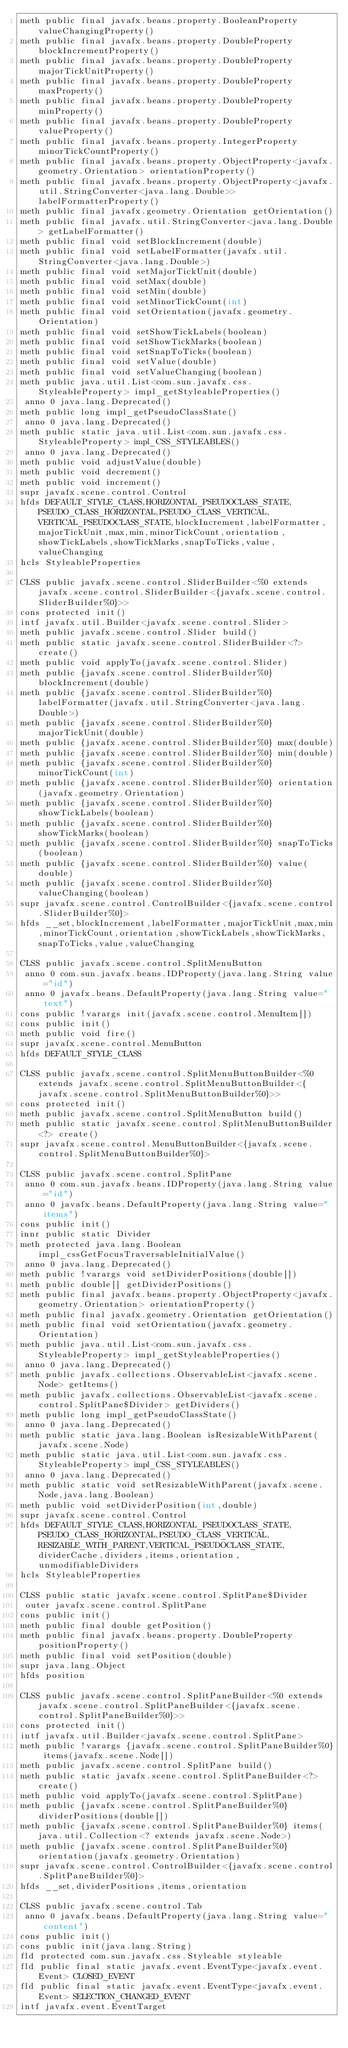<code> <loc_0><loc_0><loc_500><loc_500><_SML_>meth public final javafx.beans.property.BooleanProperty valueChangingProperty()
meth public final javafx.beans.property.DoubleProperty blockIncrementProperty()
meth public final javafx.beans.property.DoubleProperty majorTickUnitProperty()
meth public final javafx.beans.property.DoubleProperty maxProperty()
meth public final javafx.beans.property.DoubleProperty minProperty()
meth public final javafx.beans.property.DoubleProperty valueProperty()
meth public final javafx.beans.property.IntegerProperty minorTickCountProperty()
meth public final javafx.beans.property.ObjectProperty<javafx.geometry.Orientation> orientationProperty()
meth public final javafx.beans.property.ObjectProperty<javafx.util.StringConverter<java.lang.Double>> labelFormatterProperty()
meth public final javafx.geometry.Orientation getOrientation()
meth public final javafx.util.StringConverter<java.lang.Double> getLabelFormatter()
meth public final void setBlockIncrement(double)
meth public final void setLabelFormatter(javafx.util.StringConverter<java.lang.Double>)
meth public final void setMajorTickUnit(double)
meth public final void setMax(double)
meth public final void setMin(double)
meth public final void setMinorTickCount(int)
meth public final void setOrientation(javafx.geometry.Orientation)
meth public final void setShowTickLabels(boolean)
meth public final void setShowTickMarks(boolean)
meth public final void setSnapToTicks(boolean)
meth public final void setValue(double)
meth public final void setValueChanging(boolean)
meth public java.util.List<com.sun.javafx.css.StyleableProperty> impl_getStyleableProperties()
 anno 0 java.lang.Deprecated()
meth public long impl_getPseudoClassState()
 anno 0 java.lang.Deprecated()
meth public static java.util.List<com.sun.javafx.css.StyleableProperty> impl_CSS_STYLEABLES()
 anno 0 java.lang.Deprecated()
meth public void adjustValue(double)
meth public void decrement()
meth public void increment()
supr javafx.scene.control.Control
hfds DEFAULT_STYLE_CLASS,HORIZONTAL_PSEUDOCLASS_STATE,PSEUDO_CLASS_HORIZONTAL,PSEUDO_CLASS_VERTICAL,VERTICAL_PSEUDOCLASS_STATE,blockIncrement,labelFormatter,majorTickUnit,max,min,minorTickCount,orientation,showTickLabels,showTickMarks,snapToTicks,value,valueChanging
hcls StyleableProperties

CLSS public javafx.scene.control.SliderBuilder<%0 extends javafx.scene.control.SliderBuilder<{javafx.scene.control.SliderBuilder%0}>>
cons protected init()
intf javafx.util.Builder<javafx.scene.control.Slider>
meth public javafx.scene.control.Slider build()
meth public static javafx.scene.control.SliderBuilder<?> create()
meth public void applyTo(javafx.scene.control.Slider)
meth public {javafx.scene.control.SliderBuilder%0} blockIncrement(double)
meth public {javafx.scene.control.SliderBuilder%0} labelFormatter(javafx.util.StringConverter<java.lang.Double>)
meth public {javafx.scene.control.SliderBuilder%0} majorTickUnit(double)
meth public {javafx.scene.control.SliderBuilder%0} max(double)
meth public {javafx.scene.control.SliderBuilder%0} min(double)
meth public {javafx.scene.control.SliderBuilder%0} minorTickCount(int)
meth public {javafx.scene.control.SliderBuilder%0} orientation(javafx.geometry.Orientation)
meth public {javafx.scene.control.SliderBuilder%0} showTickLabels(boolean)
meth public {javafx.scene.control.SliderBuilder%0} showTickMarks(boolean)
meth public {javafx.scene.control.SliderBuilder%0} snapToTicks(boolean)
meth public {javafx.scene.control.SliderBuilder%0} value(double)
meth public {javafx.scene.control.SliderBuilder%0} valueChanging(boolean)
supr javafx.scene.control.ControlBuilder<{javafx.scene.control.SliderBuilder%0}>
hfds __set,blockIncrement,labelFormatter,majorTickUnit,max,min,minorTickCount,orientation,showTickLabels,showTickMarks,snapToTicks,value,valueChanging

CLSS public javafx.scene.control.SplitMenuButton
 anno 0 com.sun.javafx.beans.IDProperty(java.lang.String value="id")
 anno 0 javafx.beans.DefaultProperty(java.lang.String value="text")
cons public !varargs init(javafx.scene.control.MenuItem[])
cons public init()
meth public void fire()
supr javafx.scene.control.MenuButton
hfds DEFAULT_STYLE_CLASS

CLSS public javafx.scene.control.SplitMenuButtonBuilder<%0 extends javafx.scene.control.SplitMenuButtonBuilder<{javafx.scene.control.SplitMenuButtonBuilder%0}>>
cons protected init()
meth public javafx.scene.control.SplitMenuButton build()
meth public static javafx.scene.control.SplitMenuButtonBuilder<?> create()
supr javafx.scene.control.MenuButtonBuilder<{javafx.scene.control.SplitMenuButtonBuilder%0}>

CLSS public javafx.scene.control.SplitPane
 anno 0 com.sun.javafx.beans.IDProperty(java.lang.String value="id")
 anno 0 javafx.beans.DefaultProperty(java.lang.String value="items")
cons public init()
innr public static Divider
meth protected java.lang.Boolean impl_cssGetFocusTraversableInitialValue()
 anno 0 java.lang.Deprecated()
meth public !varargs void setDividerPositions(double[])
meth public double[] getDividerPositions()
meth public final javafx.beans.property.ObjectProperty<javafx.geometry.Orientation> orientationProperty()
meth public final javafx.geometry.Orientation getOrientation()
meth public final void setOrientation(javafx.geometry.Orientation)
meth public java.util.List<com.sun.javafx.css.StyleableProperty> impl_getStyleableProperties()
 anno 0 java.lang.Deprecated()
meth public javafx.collections.ObservableList<javafx.scene.Node> getItems()
meth public javafx.collections.ObservableList<javafx.scene.control.SplitPane$Divider> getDividers()
meth public long impl_getPseudoClassState()
 anno 0 java.lang.Deprecated()
meth public static java.lang.Boolean isResizableWithParent(javafx.scene.Node)
meth public static java.util.List<com.sun.javafx.css.StyleableProperty> impl_CSS_STYLEABLES()
 anno 0 java.lang.Deprecated()
meth public static void setResizableWithParent(javafx.scene.Node,java.lang.Boolean)
meth public void setDividerPosition(int,double)
supr javafx.scene.control.Control
hfds DEFAULT_STYLE_CLASS,HORIZONTAL_PSEUDOCLASS_STATE,PSEUDO_CLASS_HORIZONTAL,PSEUDO_CLASS_VERTICAL,RESIZABLE_WITH_PARENT,VERTICAL_PSEUDOCLASS_STATE,dividerCache,dividers,items,orientation,unmodifiableDividers
hcls StyleableProperties

CLSS public static javafx.scene.control.SplitPane$Divider
 outer javafx.scene.control.SplitPane
cons public init()
meth public final double getPosition()
meth public final javafx.beans.property.DoubleProperty positionProperty()
meth public final void setPosition(double)
supr java.lang.Object
hfds position

CLSS public javafx.scene.control.SplitPaneBuilder<%0 extends javafx.scene.control.SplitPaneBuilder<{javafx.scene.control.SplitPaneBuilder%0}>>
cons protected init()
intf javafx.util.Builder<javafx.scene.control.SplitPane>
meth public !varargs {javafx.scene.control.SplitPaneBuilder%0} items(javafx.scene.Node[])
meth public javafx.scene.control.SplitPane build()
meth public static javafx.scene.control.SplitPaneBuilder<?> create()
meth public void applyTo(javafx.scene.control.SplitPane)
meth public {javafx.scene.control.SplitPaneBuilder%0} dividerPositions(double[])
meth public {javafx.scene.control.SplitPaneBuilder%0} items(java.util.Collection<? extends javafx.scene.Node>)
meth public {javafx.scene.control.SplitPaneBuilder%0} orientation(javafx.geometry.Orientation)
supr javafx.scene.control.ControlBuilder<{javafx.scene.control.SplitPaneBuilder%0}>
hfds __set,dividerPositions,items,orientation

CLSS public javafx.scene.control.Tab
 anno 0 javafx.beans.DefaultProperty(java.lang.String value="content")
cons public init()
cons public init(java.lang.String)
fld protected com.sun.javafx.css.Styleable styleable
fld public final static javafx.event.EventType<javafx.event.Event> CLOSED_EVENT
fld public final static javafx.event.EventType<javafx.event.Event> SELECTION_CHANGED_EVENT
intf javafx.event.EventTarget</code> 